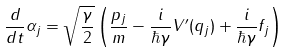<formula> <loc_0><loc_0><loc_500><loc_500>\frac { d } { d t } { \alpha _ { j } } = \sqrt { \frac { \gamma } { 2 } } \left ( \frac { p _ { j } } { m } - \frac { i } { \hbar { \gamma } } V ^ { \prime } ( q _ { j } ) + \frac { i } { \hbar { \gamma } } f _ { j } \right )</formula> 